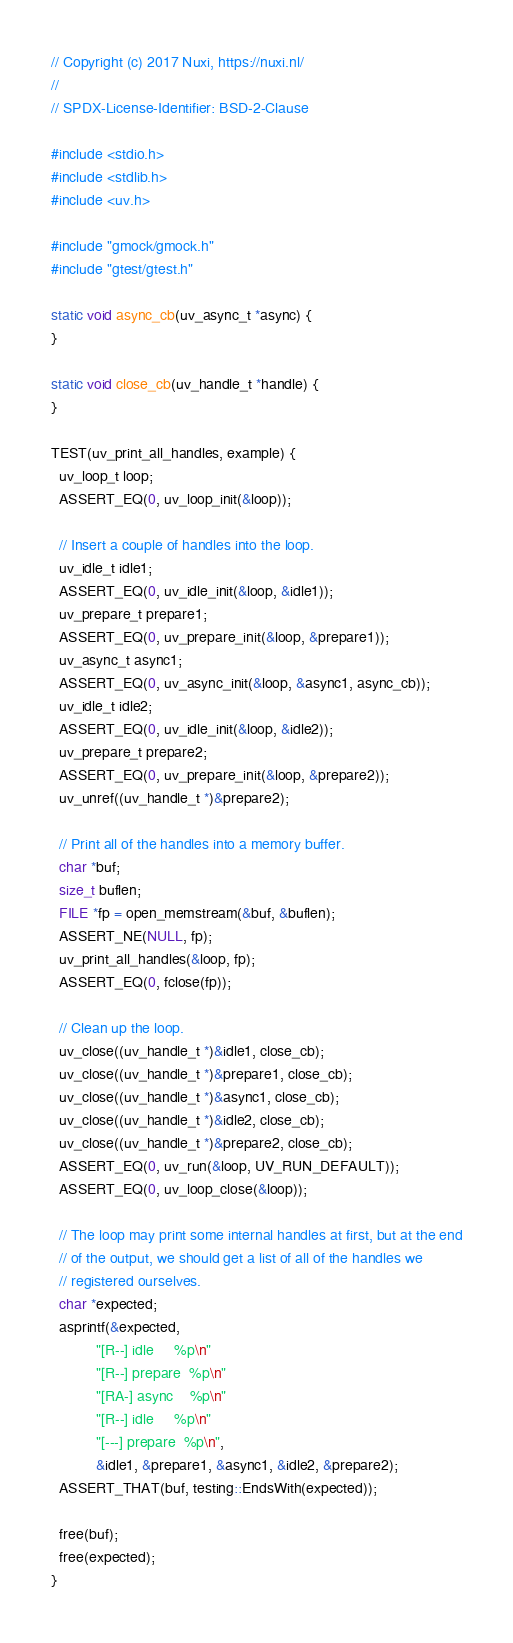<code> <loc_0><loc_0><loc_500><loc_500><_C++_>// Copyright (c) 2017 Nuxi, https://nuxi.nl/
//
// SPDX-License-Identifier: BSD-2-Clause

#include <stdio.h>
#include <stdlib.h>
#include <uv.h>

#include "gmock/gmock.h"
#include "gtest/gtest.h"

static void async_cb(uv_async_t *async) {
}

static void close_cb(uv_handle_t *handle) {
}

TEST(uv_print_all_handles, example) {
  uv_loop_t loop;
  ASSERT_EQ(0, uv_loop_init(&loop));

  // Insert a couple of handles into the loop.
  uv_idle_t idle1;
  ASSERT_EQ(0, uv_idle_init(&loop, &idle1));
  uv_prepare_t prepare1;
  ASSERT_EQ(0, uv_prepare_init(&loop, &prepare1));
  uv_async_t async1;
  ASSERT_EQ(0, uv_async_init(&loop, &async1, async_cb));
  uv_idle_t idle2;
  ASSERT_EQ(0, uv_idle_init(&loop, &idle2));
  uv_prepare_t prepare2;
  ASSERT_EQ(0, uv_prepare_init(&loop, &prepare2));
  uv_unref((uv_handle_t *)&prepare2);

  // Print all of the handles into a memory buffer.
  char *buf;
  size_t buflen;
  FILE *fp = open_memstream(&buf, &buflen);
  ASSERT_NE(NULL, fp);
  uv_print_all_handles(&loop, fp);
  ASSERT_EQ(0, fclose(fp));

  // Clean up the loop.
  uv_close((uv_handle_t *)&idle1, close_cb);
  uv_close((uv_handle_t *)&prepare1, close_cb);
  uv_close((uv_handle_t *)&async1, close_cb);
  uv_close((uv_handle_t *)&idle2, close_cb);
  uv_close((uv_handle_t *)&prepare2, close_cb);
  ASSERT_EQ(0, uv_run(&loop, UV_RUN_DEFAULT));
  ASSERT_EQ(0, uv_loop_close(&loop));

  // The loop may print some internal handles at first, but at the end
  // of the output, we should get a list of all of the handles we
  // registered ourselves.
  char *expected;
  asprintf(&expected,
           "[R--] idle     %p\n"
           "[R--] prepare  %p\n"
           "[RA-] async    %p\n"
           "[R--] idle     %p\n"
           "[---] prepare  %p\n",
           &idle1, &prepare1, &async1, &idle2, &prepare2);
  ASSERT_THAT(buf, testing::EndsWith(expected));

  free(buf);
  free(expected);
}
</code> 